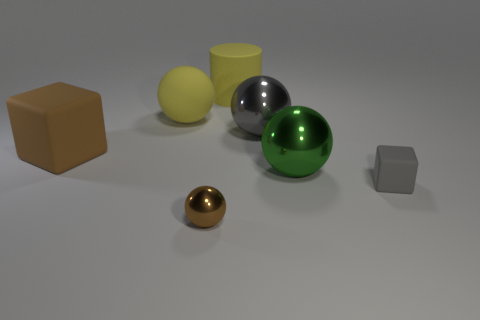Subtract all gray shiny balls. How many balls are left? 3 Add 2 cyan balls. How many objects exist? 9 Subtract all yellow balls. How many balls are left? 3 Subtract all cylinders. How many objects are left? 6 Subtract all cyan blocks. Subtract all purple cylinders. How many blocks are left? 2 Subtract all tiny gray matte things. Subtract all small brown metallic things. How many objects are left? 5 Add 7 tiny brown shiny things. How many tiny brown shiny things are left? 8 Add 6 green spheres. How many green spheres exist? 7 Subtract 0 red cylinders. How many objects are left? 7 